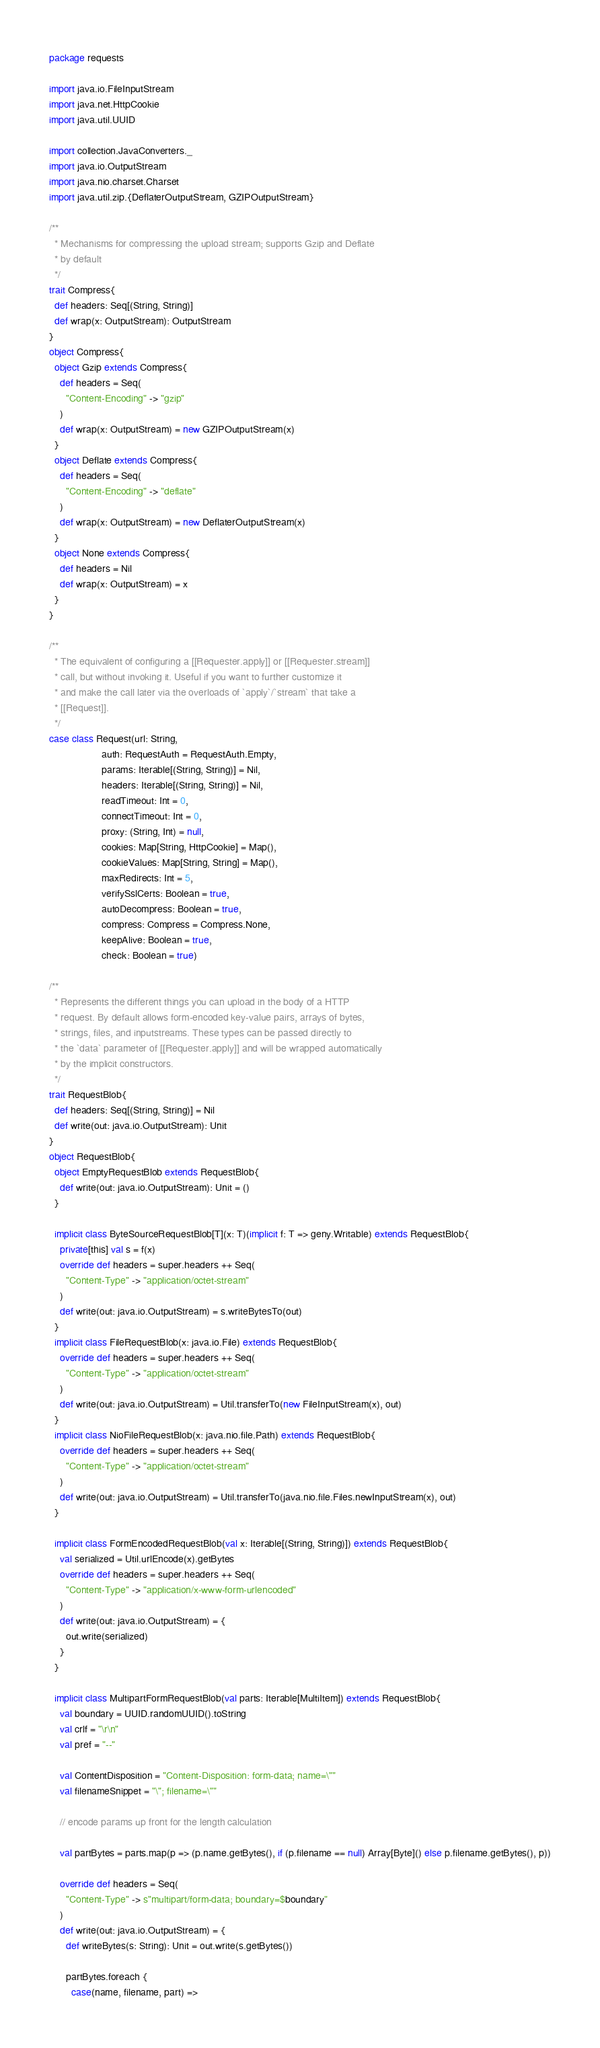Convert code to text. <code><loc_0><loc_0><loc_500><loc_500><_Scala_>package requests

import java.io.FileInputStream
import java.net.HttpCookie
import java.util.UUID

import collection.JavaConverters._
import java.io.OutputStream
import java.nio.charset.Charset
import java.util.zip.{DeflaterOutputStream, GZIPOutputStream}

/**
  * Mechanisms for compressing the upload stream; supports Gzip and Deflate
  * by default
  */
trait Compress{
  def headers: Seq[(String, String)]
  def wrap(x: OutputStream): OutputStream
}
object Compress{
  object Gzip extends Compress{
    def headers = Seq(
      "Content-Encoding" -> "gzip"
    )
    def wrap(x: OutputStream) = new GZIPOutputStream(x)
  }
  object Deflate extends Compress{
    def headers = Seq(
      "Content-Encoding" -> "deflate"
    )
    def wrap(x: OutputStream) = new DeflaterOutputStream(x)
  }
  object None extends Compress{
    def headers = Nil
    def wrap(x: OutputStream) = x
  }
}

/**
  * The equivalent of configuring a [[Requester.apply]] or [[Requester.stream]]
  * call, but without invoking it. Useful if you want to further customize it
  * and make the call later via the overloads of `apply`/`stream` that take a
  * [[Request]].
  */
case class Request(url: String,
                   auth: RequestAuth = RequestAuth.Empty,
                   params: Iterable[(String, String)] = Nil,
                   headers: Iterable[(String, String)] = Nil,
                   readTimeout: Int = 0,
                   connectTimeout: Int = 0,
                   proxy: (String, Int) = null,
                   cookies: Map[String, HttpCookie] = Map(),
                   cookieValues: Map[String, String] = Map(),
                   maxRedirects: Int = 5,
                   verifySslCerts: Boolean = true,
                   autoDecompress: Boolean = true,
                   compress: Compress = Compress.None,
                   keepAlive: Boolean = true,
                   check: Boolean = true)

/**
  * Represents the different things you can upload in the body of a HTTP
  * request. By default allows form-encoded key-value pairs, arrays of bytes,
  * strings, files, and inputstreams. These types can be passed directly to
  * the `data` parameter of [[Requester.apply]] and will be wrapped automatically
  * by the implicit constructors.
  */
trait RequestBlob{
  def headers: Seq[(String, String)] = Nil
  def write(out: java.io.OutputStream): Unit
}
object RequestBlob{
  object EmptyRequestBlob extends RequestBlob{
    def write(out: java.io.OutputStream): Unit = ()
  }

  implicit class ByteSourceRequestBlob[T](x: T)(implicit f: T => geny.Writable) extends RequestBlob{
    private[this] val s = f(x)
    override def headers = super.headers ++ Seq(
      "Content-Type" -> "application/octet-stream"
    )
    def write(out: java.io.OutputStream) = s.writeBytesTo(out)
  }
  implicit class FileRequestBlob(x: java.io.File) extends RequestBlob{
    override def headers = super.headers ++ Seq(
      "Content-Type" -> "application/octet-stream"
    )
    def write(out: java.io.OutputStream) = Util.transferTo(new FileInputStream(x), out)
  }
  implicit class NioFileRequestBlob(x: java.nio.file.Path) extends RequestBlob{
    override def headers = super.headers ++ Seq(
      "Content-Type" -> "application/octet-stream"
    )
    def write(out: java.io.OutputStream) = Util.transferTo(java.nio.file.Files.newInputStream(x), out)
  }

  implicit class FormEncodedRequestBlob(val x: Iterable[(String, String)]) extends RequestBlob{
    val serialized = Util.urlEncode(x).getBytes
    override def headers = super.headers ++ Seq(
      "Content-Type" -> "application/x-www-form-urlencoded"
    )
    def write(out: java.io.OutputStream) = {
      out.write(serialized)
    }
  }

  implicit class MultipartFormRequestBlob(val parts: Iterable[MultiItem]) extends RequestBlob{
    val boundary = UUID.randomUUID().toString
    val crlf = "\r\n"
    val pref = "--"

    val ContentDisposition = "Content-Disposition: form-data; name=\""
    val filenameSnippet = "\"; filename=\""

    // encode params up front for the length calculation

    val partBytes = parts.map(p => (p.name.getBytes(), if (p.filename == null) Array[Byte]() else p.filename.getBytes(), p))

    override def headers = Seq(
      "Content-Type" -> s"multipart/form-data; boundary=$boundary"
    )
    def write(out: java.io.OutputStream) = {
      def writeBytes(s: String): Unit = out.write(s.getBytes())

      partBytes.foreach {
        case(name, filename, part) =></code> 